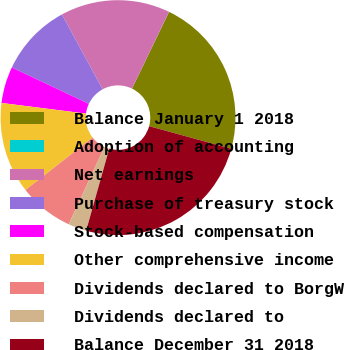Convert chart to OTSL. <chart><loc_0><loc_0><loc_500><loc_500><pie_chart><fcel>Balance January 1 2018<fcel>Adoption of accounting<fcel>Net earnings<fcel>Purchase of treasury stock<fcel>Stock-based compensation<fcel>Other comprehensive income<fcel>Dividends declared to BorgW<fcel>Dividends declared to<fcel>Balance December 31 2018<nl><fcel>22.11%<fcel>0.01%<fcel>15.07%<fcel>10.05%<fcel>5.03%<fcel>12.56%<fcel>7.54%<fcel>2.52%<fcel>25.11%<nl></chart> 